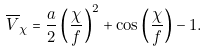Convert formula to latex. <formula><loc_0><loc_0><loc_500><loc_500>\overline { V } _ { \chi } = \frac { a } { 2 } \left ( \frac { \chi } { f } \right ) ^ { 2 } + \cos \left ( \frac { \chi } { f } \right ) - 1 .</formula> 